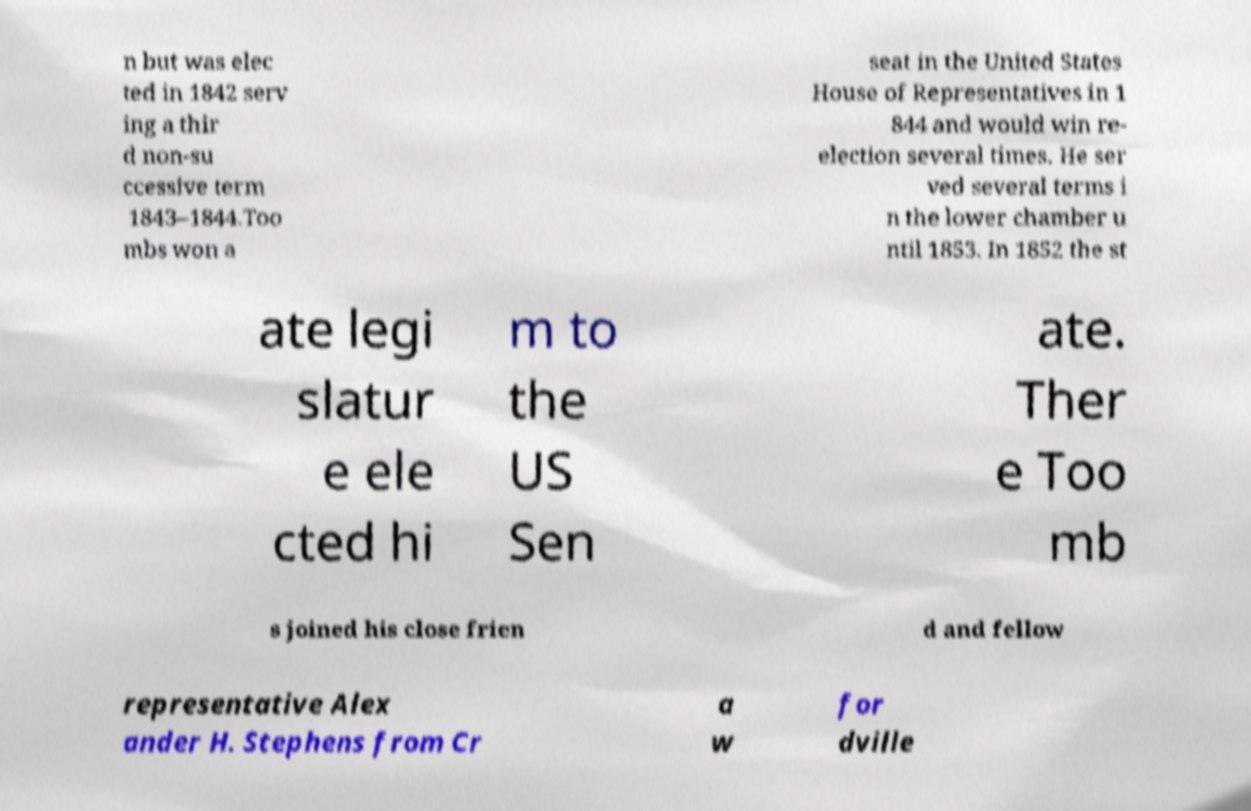Can you read and provide the text displayed in the image?This photo seems to have some interesting text. Can you extract and type it out for me? n but was elec ted in 1842 serv ing a thir d non-su ccessive term 1843–1844.Too mbs won a seat in the United States House of Representatives in 1 844 and would win re- election several times. He ser ved several terms i n the lower chamber u ntil 1853. In 1852 the st ate legi slatur e ele cted hi m to the US Sen ate. Ther e Too mb s joined his close frien d and fellow representative Alex ander H. Stephens from Cr a w for dville 